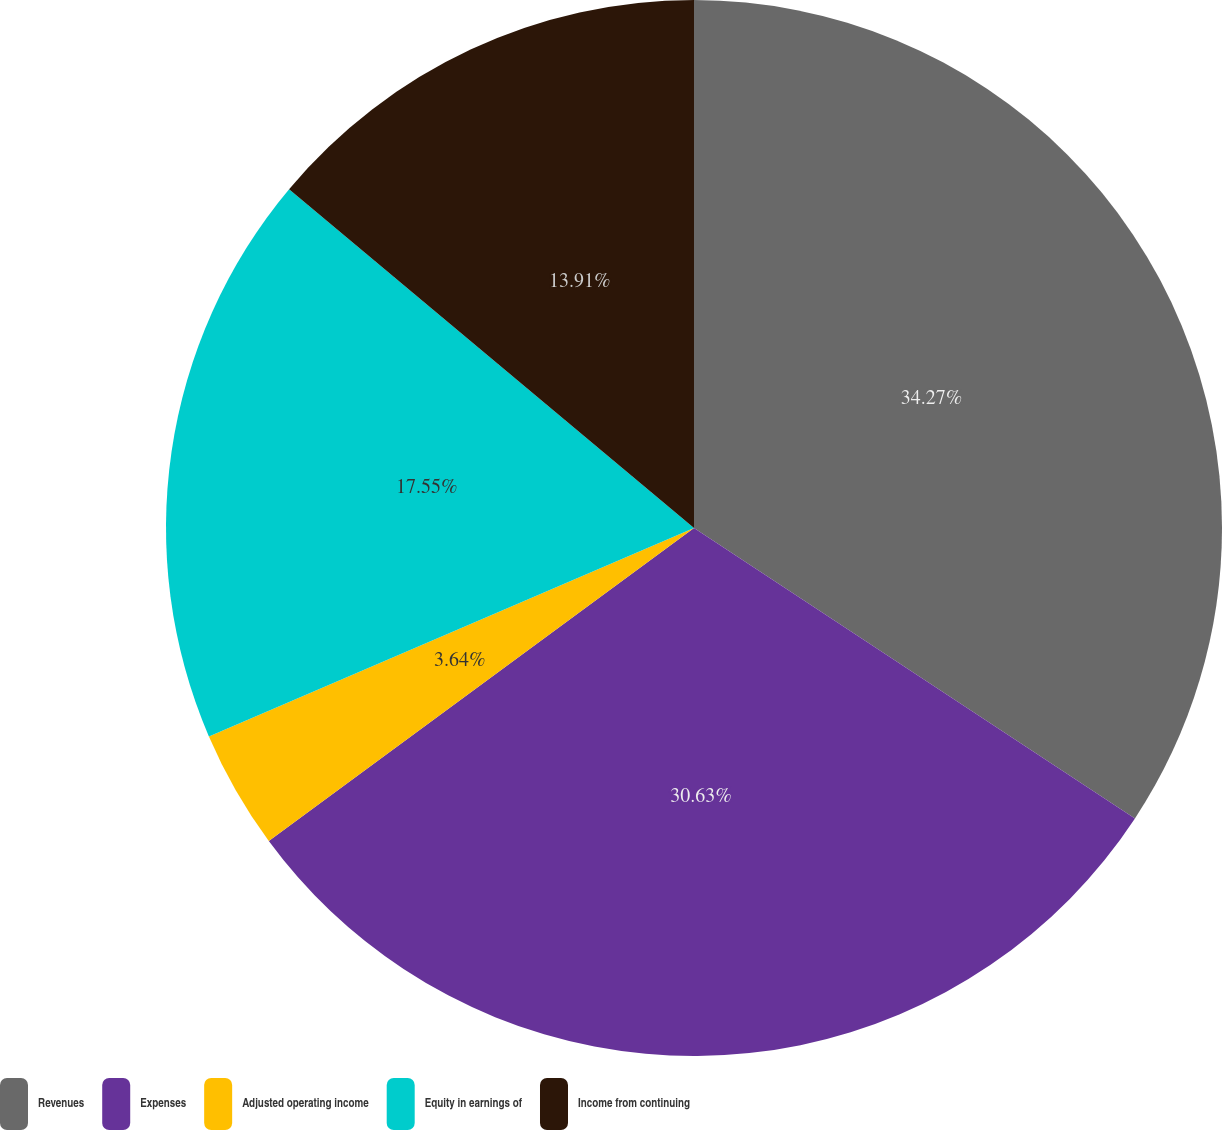Convert chart. <chart><loc_0><loc_0><loc_500><loc_500><pie_chart><fcel>Revenues<fcel>Expenses<fcel>Adjusted operating income<fcel>Equity in earnings of<fcel>Income from continuing<nl><fcel>34.27%<fcel>30.63%<fcel>3.64%<fcel>17.55%<fcel>13.91%<nl></chart> 